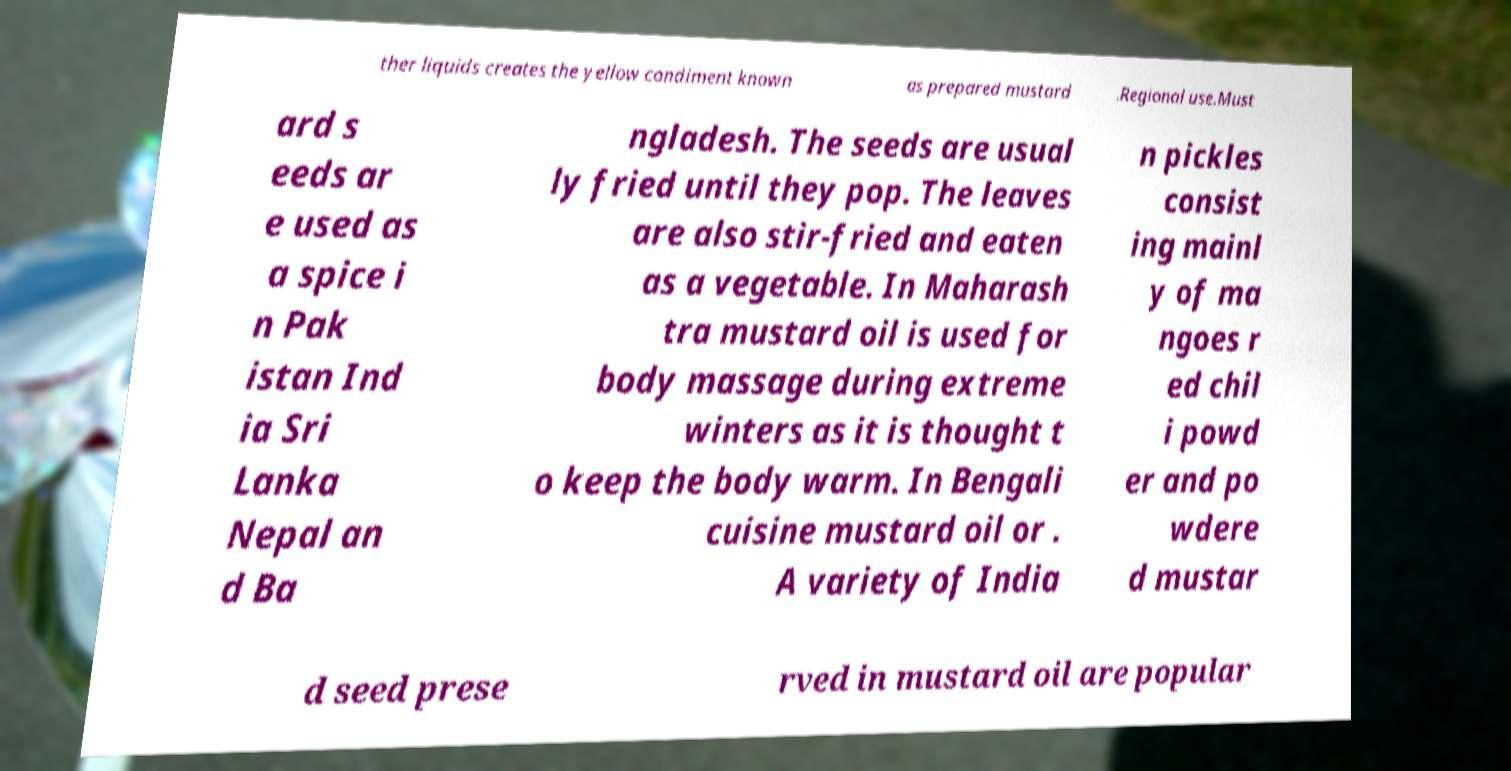Please read and relay the text visible in this image. What does it say? ther liquids creates the yellow condiment known as prepared mustard .Regional use.Must ard s eeds ar e used as a spice i n Pak istan Ind ia Sri Lanka Nepal an d Ba ngladesh. The seeds are usual ly fried until they pop. The leaves are also stir-fried and eaten as a vegetable. In Maharash tra mustard oil is used for body massage during extreme winters as it is thought t o keep the body warm. In Bengali cuisine mustard oil or . A variety of India n pickles consist ing mainl y of ma ngoes r ed chil i powd er and po wdere d mustar d seed prese rved in mustard oil are popular 